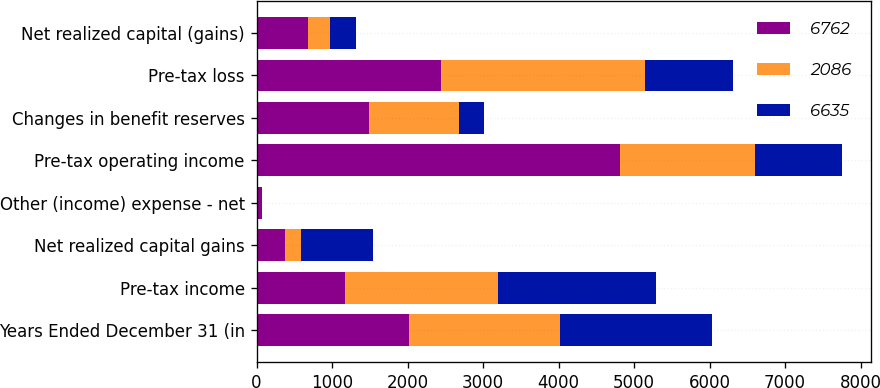<chart> <loc_0><loc_0><loc_500><loc_500><stacked_bar_chart><ecel><fcel>Years Ended December 31 (in<fcel>Pre-tax income<fcel>Net realized capital gains<fcel>Other (income) expense - net<fcel>Pre-tax operating income<fcel>Changes in benefit reserves<fcel>Pre-tax loss<fcel>Net realized capital (gains)<nl><fcel>6762<fcel>2013<fcel>1174.5<fcel>380<fcel>72<fcel>4812<fcel>1486<fcel>2449<fcel>685<nl><fcel>2086<fcel>2012<fcel>2023<fcel>211<fcel>2<fcel>1793<fcel>1201<fcel>2690<fcel>289<nl><fcel>6635<fcel>2011<fcel>2100<fcel>957<fcel>5<fcel>1148<fcel>327<fcel>1174.5<fcel>348<nl></chart> 